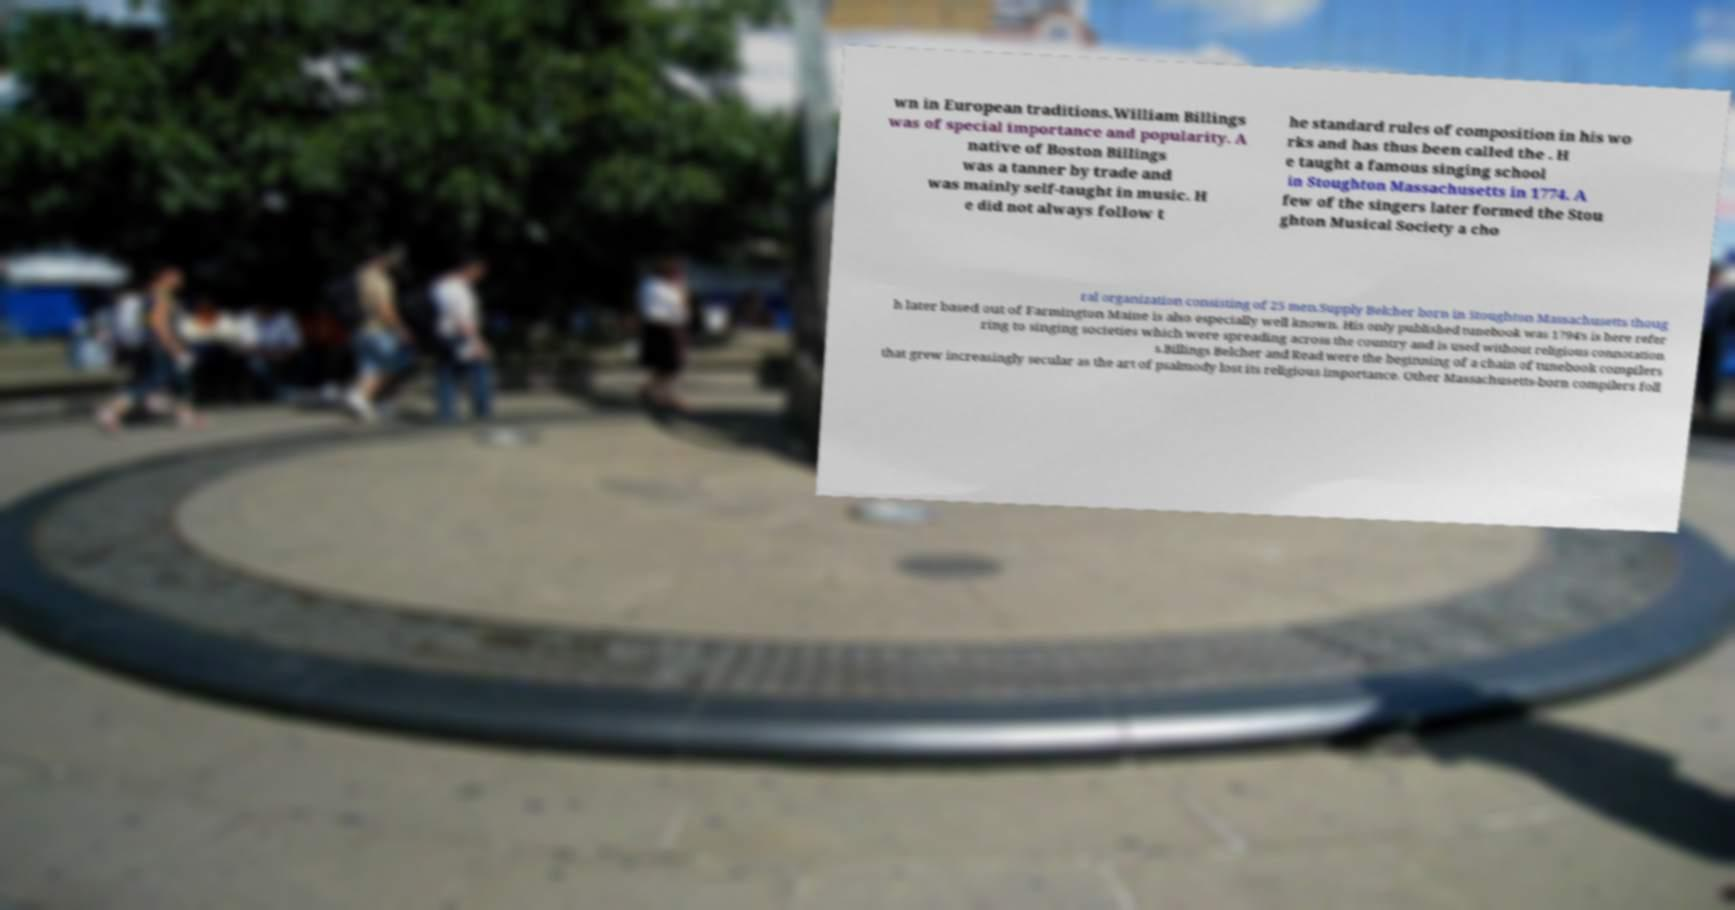Could you extract and type out the text from this image? wn in European traditions.William Billings was of special importance and popularity. A native of Boston Billings was a tanner by trade and was mainly self-taught in music. H e did not always follow t he standard rules of composition in his wo rks and has thus been called the . H e taught a famous singing school in Stoughton Massachusetts in 1774. A few of the singers later formed the Stou ghton Musical Society a cho ral organization consisting of 25 men.Supply Belcher born in Stoughton Massachusetts thoug h later based out of Farmington Maine is also especially well known. His only published tunebook was 1794's is here refer ring to singing societies which were spreading across the country and is used without religious connotation s.Billings Belcher and Read were the beginning of a chain of tunebook compilers that grew increasingly secular as the art of psalmody lost its religious importance. Other Massachusetts-born compilers foll 